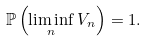<formula> <loc_0><loc_0><loc_500><loc_500>\mathbb { P } \left ( \liminf _ { n } V _ { n } \right ) = 1 .</formula> 